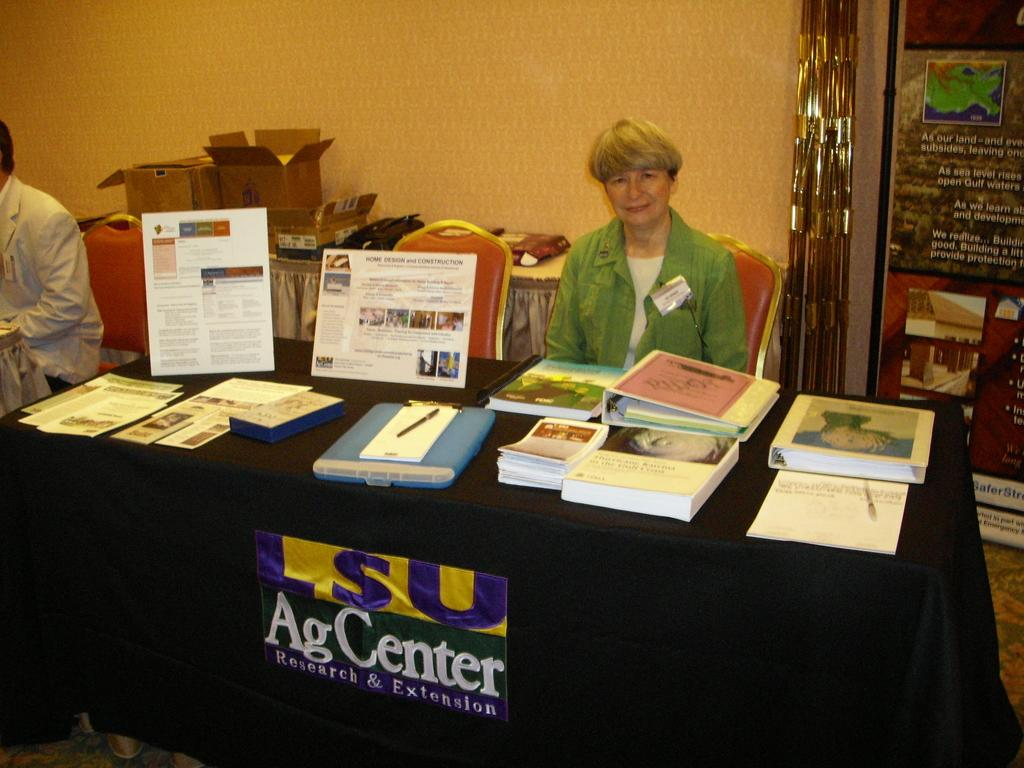<image>
Provide a brief description of the given image. A  promotion table with representative and information for SU Agcenter research & Extension. 